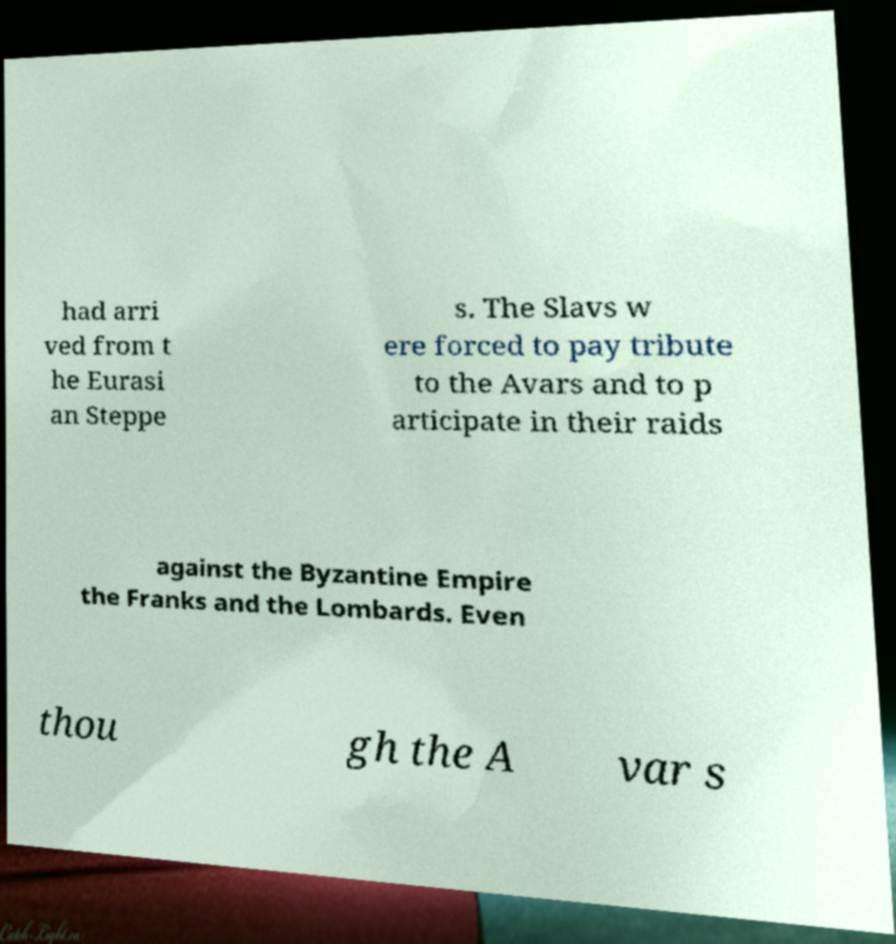Please identify and transcribe the text found in this image. had arri ved from t he Eurasi an Steppe s. The Slavs w ere forced to pay tribute to the Avars and to p articipate in their raids against the Byzantine Empire the Franks and the Lombards. Even thou gh the A var s 